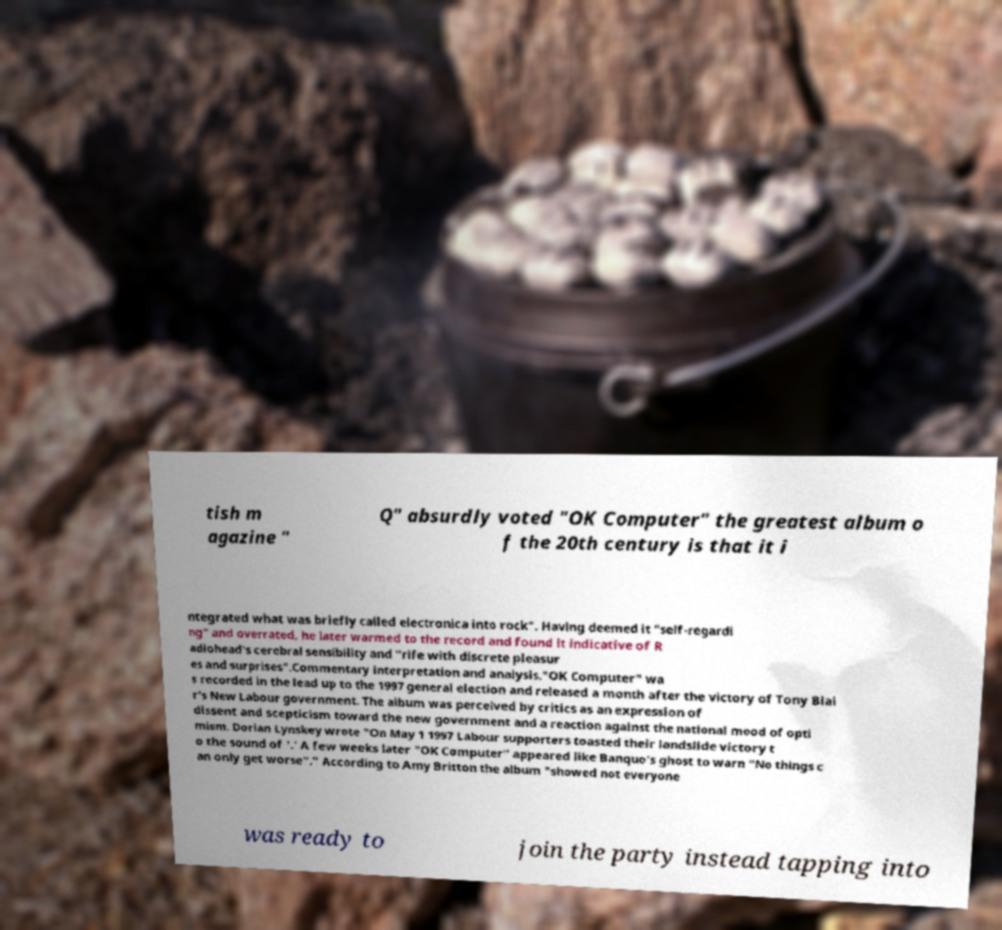For documentation purposes, I need the text within this image transcribed. Could you provide that? tish m agazine " Q" absurdly voted "OK Computer" the greatest album o f the 20th century is that it i ntegrated what was briefly called electronica into rock". Having deemed it "self-regardi ng" and overrated, he later warmed to the record and found it indicative of R adiohead's cerebral sensibility and "rife with discrete pleasur es and surprises".Commentary interpretation and analysis."OK Computer" wa s recorded in the lead up to the 1997 general election and released a month after the victory of Tony Blai r's New Labour government. The album was perceived by critics as an expression of dissent and scepticism toward the new government and a reaction against the national mood of opti mism. Dorian Lynskey wrote "On May 1 1997 Labour supporters toasted their landslide victory t o the sound of '.' A few weeks later "OK Computer" appeared like Banquo's ghost to warn "No things c an only get worse"." According to Amy Britton the album "showed not everyone was ready to join the party instead tapping into 